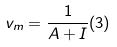Convert formula to latex. <formula><loc_0><loc_0><loc_500><loc_500>v _ { m } = \frac { 1 } { A + I } ( 3 )</formula> 